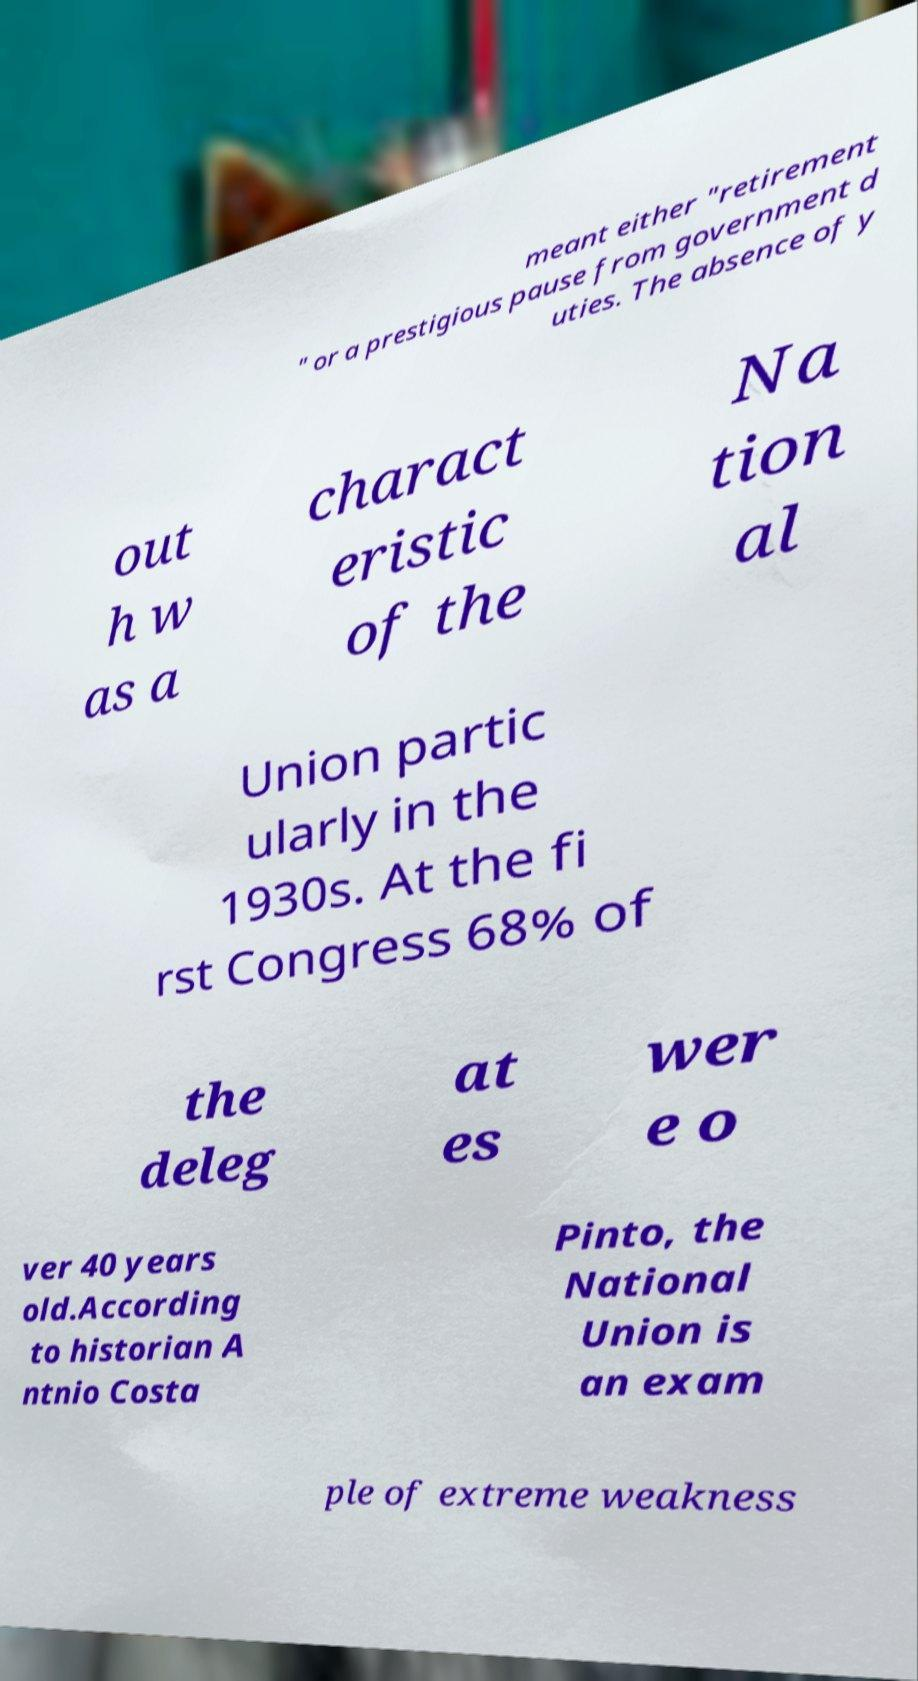Can you accurately transcribe the text from the provided image for me? meant either "retirement " or a prestigious pause from government d uties. The absence of y out h w as a charact eristic of the Na tion al Union partic ularly in the 1930s. At the fi rst Congress 68% of the deleg at es wer e o ver 40 years old.According to historian A ntnio Costa Pinto, the National Union is an exam ple of extreme weakness 